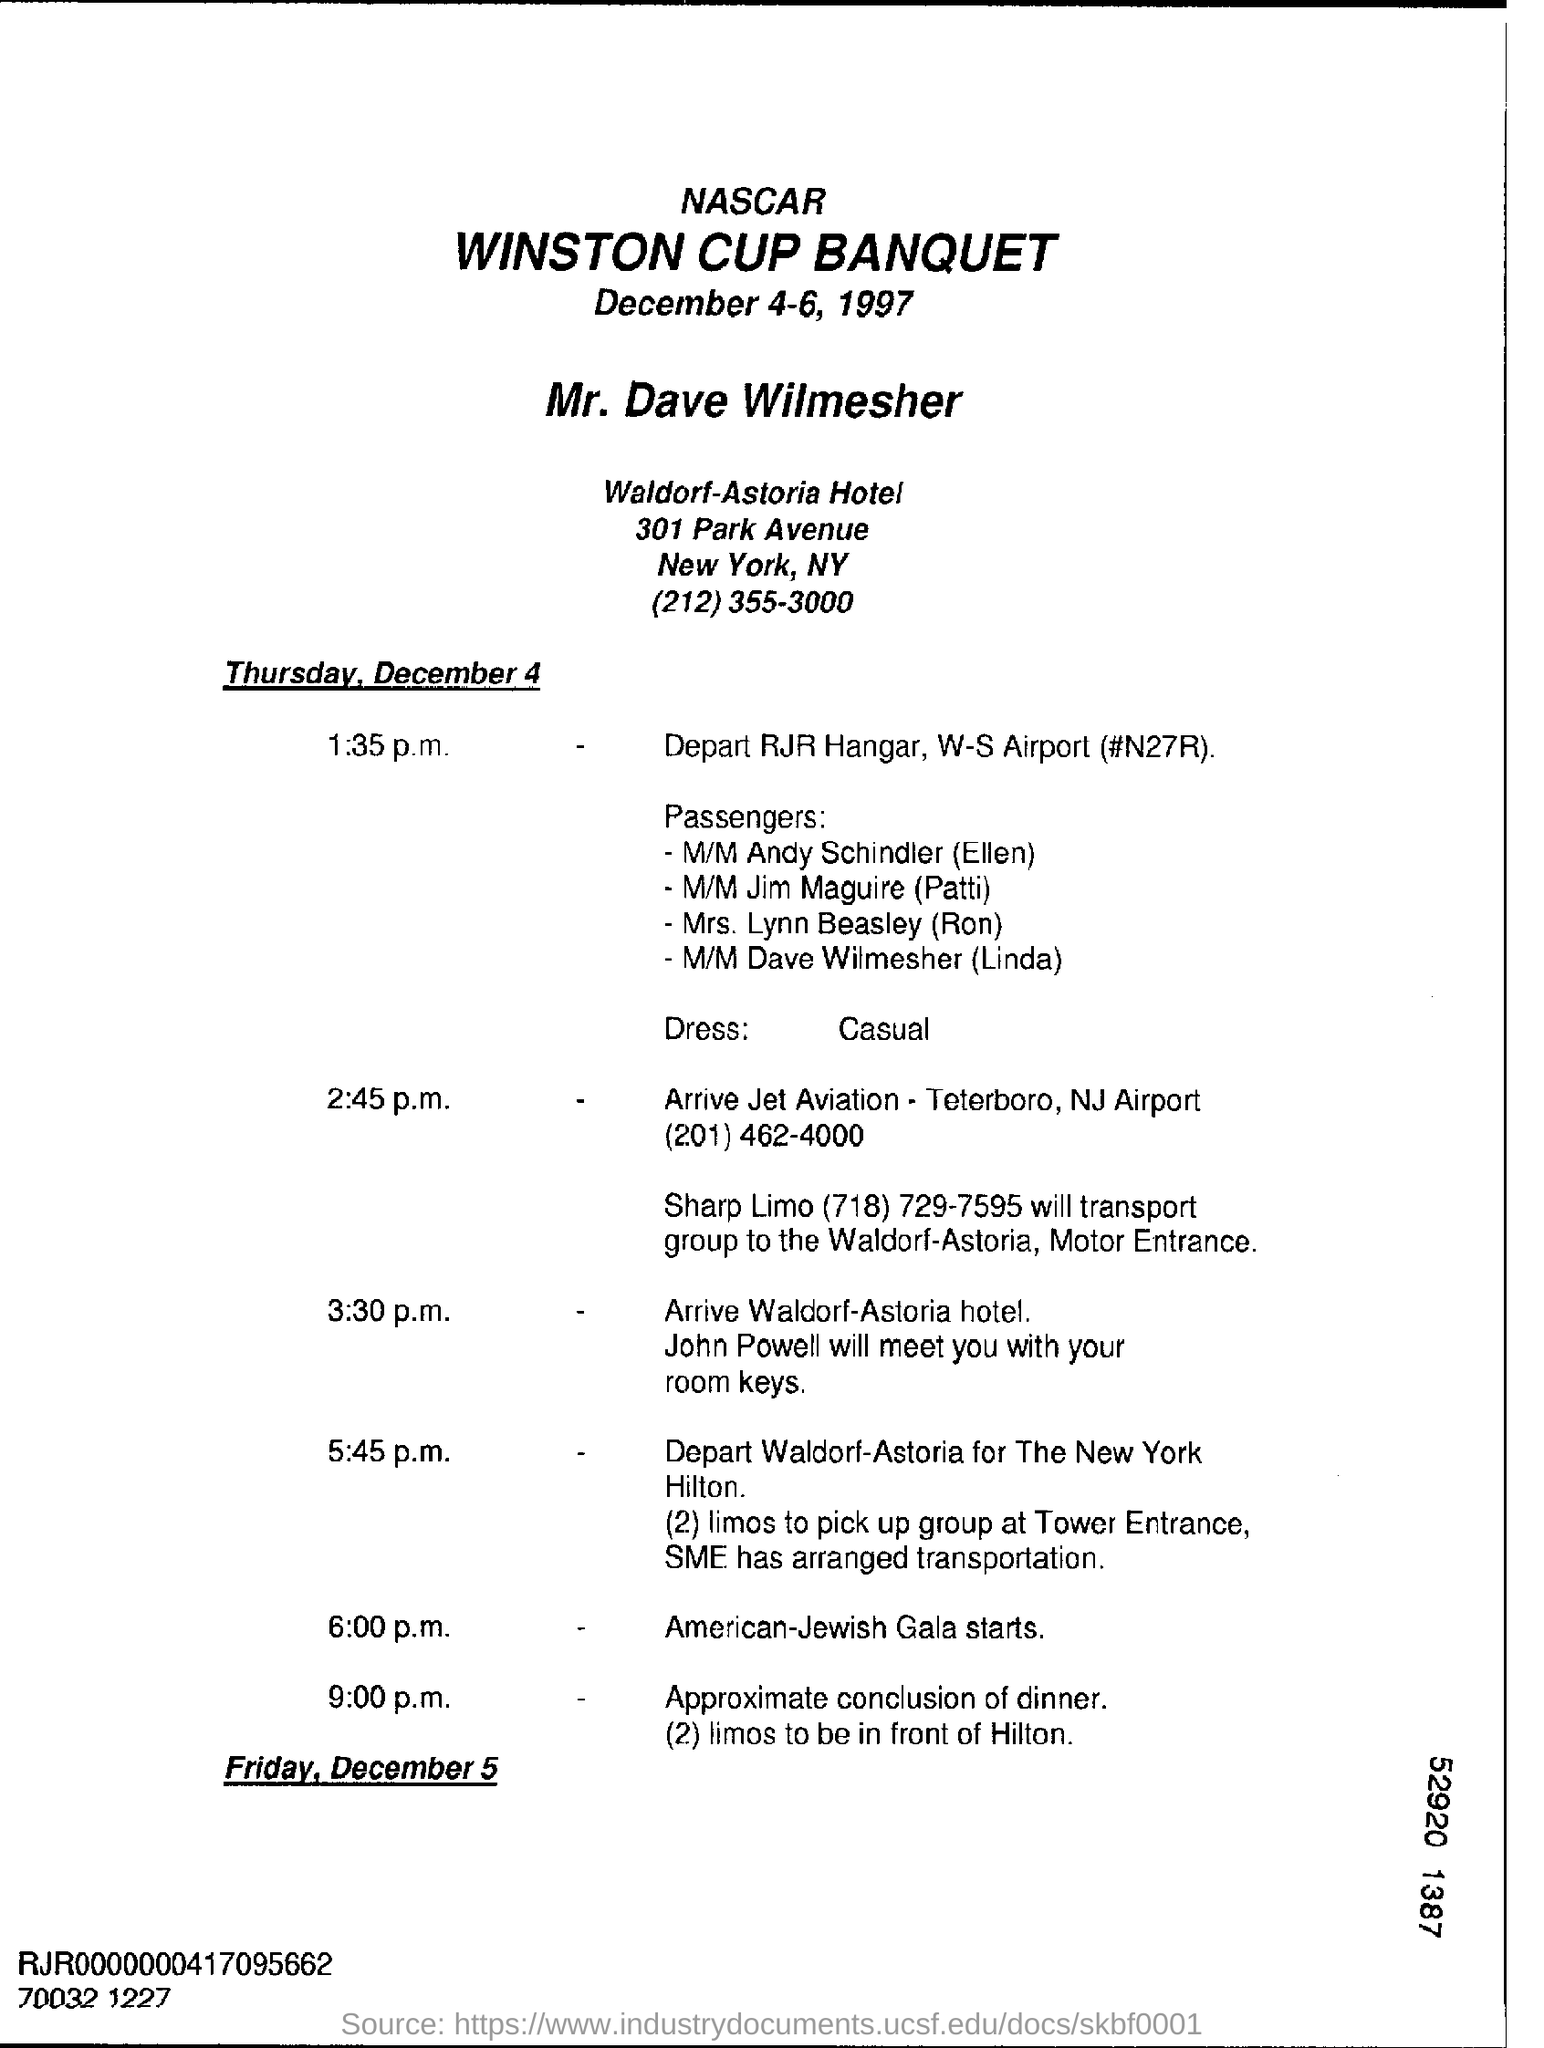List a handful of essential elements in this visual. The Waldorf-Astoria Hotel is the name of the hotel. The American-Jewish Gala is scheduled to begin at 6:00 p.m. The Winston Cup Banquet will be held from December 4-6, 1997. 